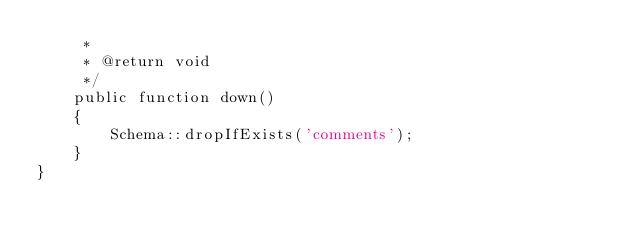Convert code to text. <code><loc_0><loc_0><loc_500><loc_500><_PHP_>     *
     * @return void
     */
    public function down()
    {
        Schema::dropIfExists('comments');
    }
}
</code> 